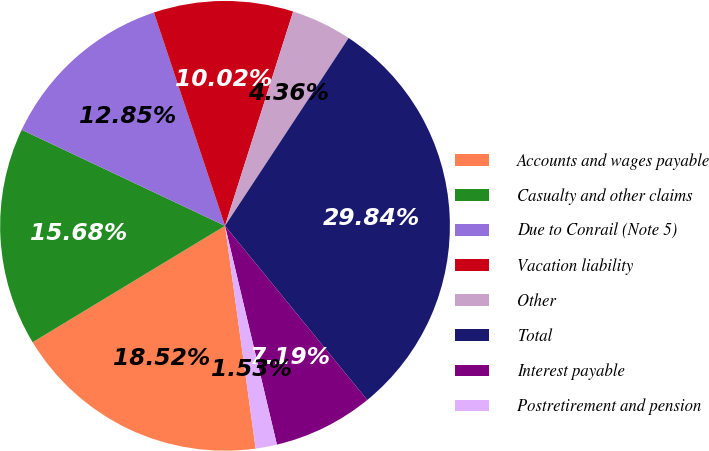Convert chart. <chart><loc_0><loc_0><loc_500><loc_500><pie_chart><fcel>Accounts and wages payable<fcel>Casualty and other claims<fcel>Due to Conrail (Note 5)<fcel>Vacation liability<fcel>Other<fcel>Total<fcel>Interest payable<fcel>Postretirement and pension<nl><fcel>18.51%<fcel>15.68%<fcel>12.85%<fcel>10.02%<fcel>4.36%<fcel>29.83%<fcel>7.19%<fcel>1.53%<nl></chart> 